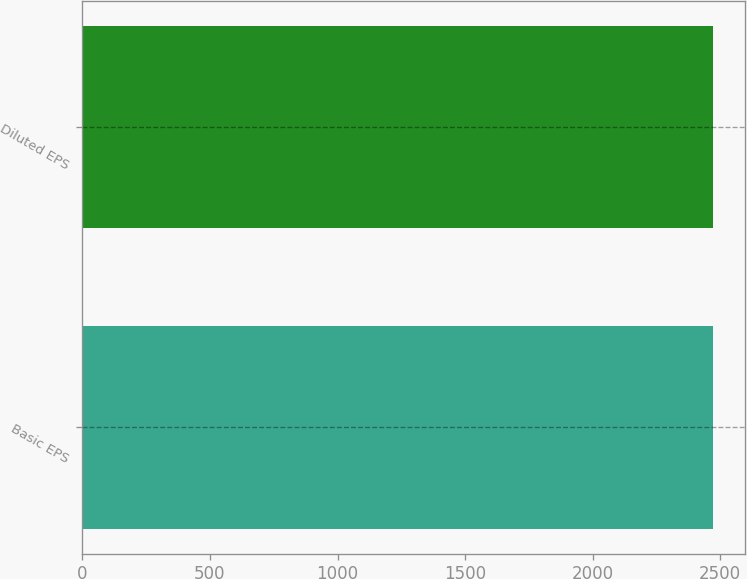Convert chart. <chart><loc_0><loc_0><loc_500><loc_500><bar_chart><fcel>Basic EPS<fcel>Diluted EPS<nl><fcel>2472<fcel>2472.1<nl></chart> 